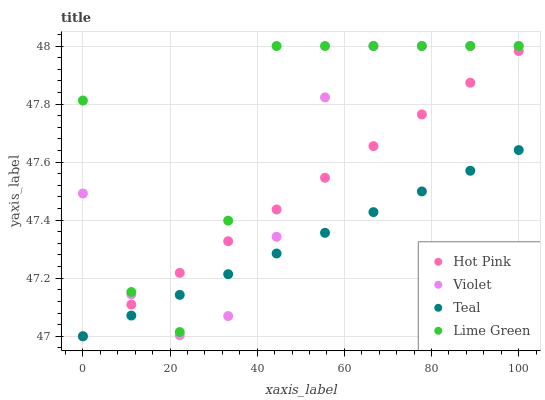Does Teal have the minimum area under the curve?
Answer yes or no. Yes. Does Lime Green have the maximum area under the curve?
Answer yes or no. Yes. Does Lime Green have the minimum area under the curve?
Answer yes or no. No. Does Teal have the maximum area under the curve?
Answer yes or no. No. Is Hot Pink the smoothest?
Answer yes or no. Yes. Is Lime Green the roughest?
Answer yes or no. Yes. Is Teal the smoothest?
Answer yes or no. No. Is Teal the roughest?
Answer yes or no. No. Does Hot Pink have the lowest value?
Answer yes or no. Yes. Does Lime Green have the lowest value?
Answer yes or no. No. Does Violet have the highest value?
Answer yes or no. Yes. Does Teal have the highest value?
Answer yes or no. No. Does Violet intersect Lime Green?
Answer yes or no. Yes. Is Violet less than Lime Green?
Answer yes or no. No. Is Violet greater than Lime Green?
Answer yes or no. No. 